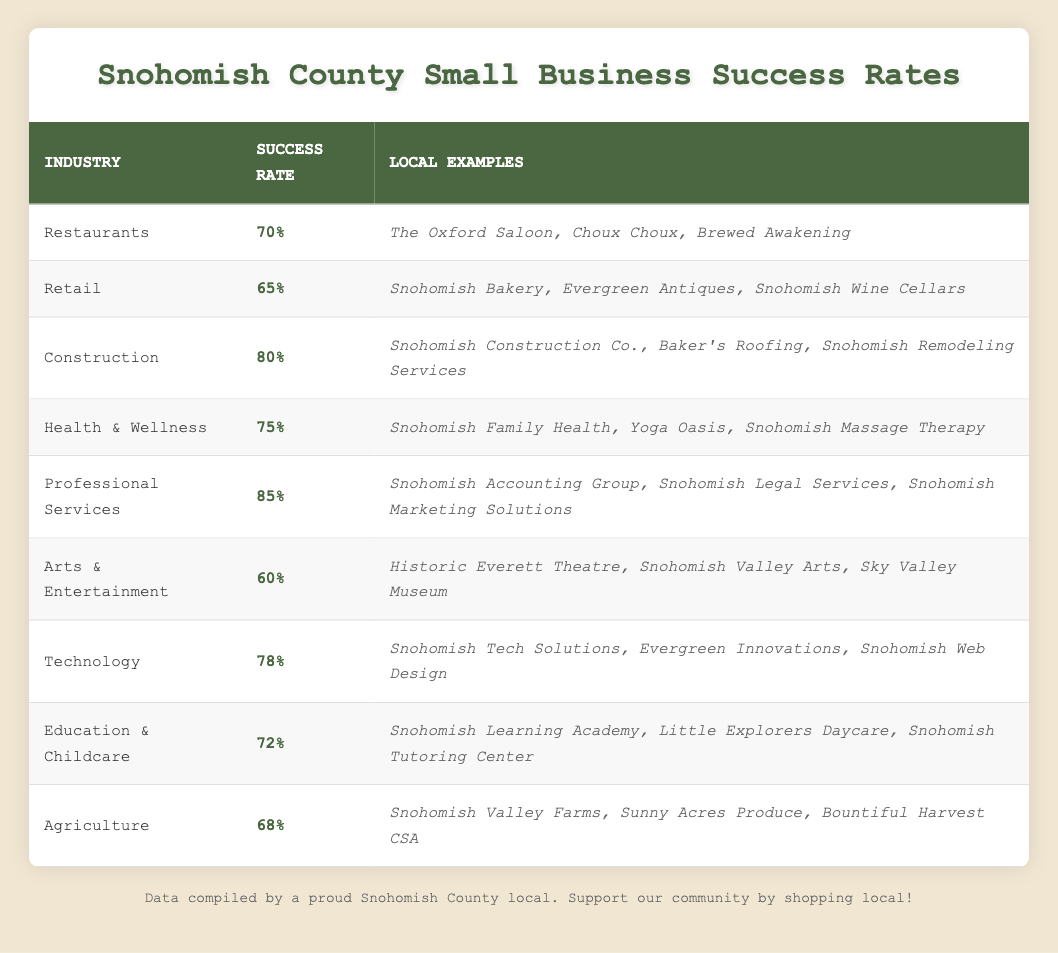What is the success rate of Professional Services in Snohomish County? The table lists the success rate for the Professional Services industry as 85%.
Answer: 85% Which industry has the lowest success rate? The industry with the lowest success rate according to the table is Arts & Entertainment, which has a success rate of 60%.
Answer: Arts & Entertainment What is the average success rate of Health & Wellness and Education & Childcare? The success rate for Health & Wellness is 75%, and for Education & Childcare, it is 72%. To find the average, we add the two rates: 75 + 72 = 147, and then divide by 2, which gives us 147 / 2 = 73.5.
Answer: 73.5 Is the success rate of Retail higher than that of Agriculture? The success rate for Retail is 65%, and for Agriculture, it is 68%. Since 65% is less than 68%, the answer is no.
Answer: No Which industries have a success rate above 75%? From the table, Construction (80%), Health & Wellness (75%), and Professional Services (85%) all have success rates above 75%.
Answer: Construction, Health & Wellness, Professional Services What is the difference in success rate between Construction and Technology? The success rate for Construction is 80%, and for Technology, it is 78%. The difference is calculated by subtracting the Technology success rate from the Construction success rate: 80 - 78 = 2.
Answer: 2 Which industry has a success rate of 70%? According to the table, the industry that has a success rate of 70% is Restaurants.
Answer: Restaurants Are there more examples listed for Agriculture than for Arts & Entertainment? Agriculture lists three examples (Snohomish Valley Farms, Sunny Acres Produce, Bountiful Harvest CSA), and Arts & Entertainment also lists three examples (Historic Everett Theatre, Snohomish Valley Arts, Sky Valley Museum). Since both have the same number of examples, the answer is no.
Answer: No 